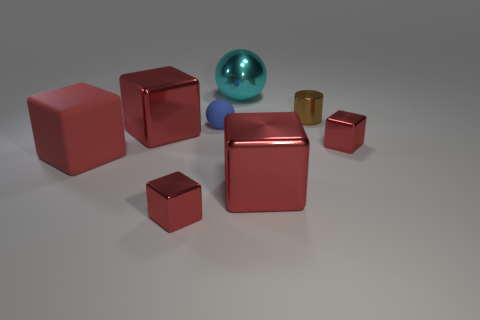There is a blue matte object that is the same shape as the large cyan metal object; what is its size?
Offer a terse response. Small. There is a rubber object that is the same size as the metallic sphere; what color is it?
Provide a succinct answer. Red. How many other large cyan metallic things are the same shape as the cyan shiny object?
Provide a succinct answer. 0. Are the tiny red cube to the left of the blue matte object and the cylinder made of the same material?
Your answer should be very brief. Yes. What number of cylinders are either tiny red metallic objects or large rubber objects?
Your answer should be compact. 0. What is the shape of the small brown thing that is behind the small red metal cube on the right side of the small red block that is left of the large shiny ball?
Provide a succinct answer. Cylinder. How many yellow blocks have the same size as the blue matte object?
Give a very brief answer. 0. There is a big red shiny block right of the cyan object; is there a red block to the right of it?
Your answer should be very brief. Yes. What number of things are either tiny brown metallic objects or big gray matte balls?
Your response must be concise. 1. There is a large object in front of the large cube to the left of the large shiny thing left of the big sphere; what is its color?
Your answer should be very brief. Red. 